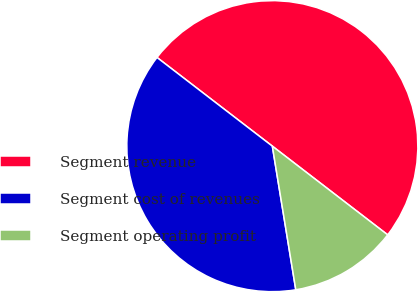<chart> <loc_0><loc_0><loc_500><loc_500><pie_chart><fcel>Segment revenue<fcel>Segment cost of revenues<fcel>Segment operating profit<nl><fcel>50.0%<fcel>38.01%<fcel>11.99%<nl></chart> 